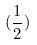<formula> <loc_0><loc_0><loc_500><loc_500>( \frac { 1 } { 2 } )</formula> 